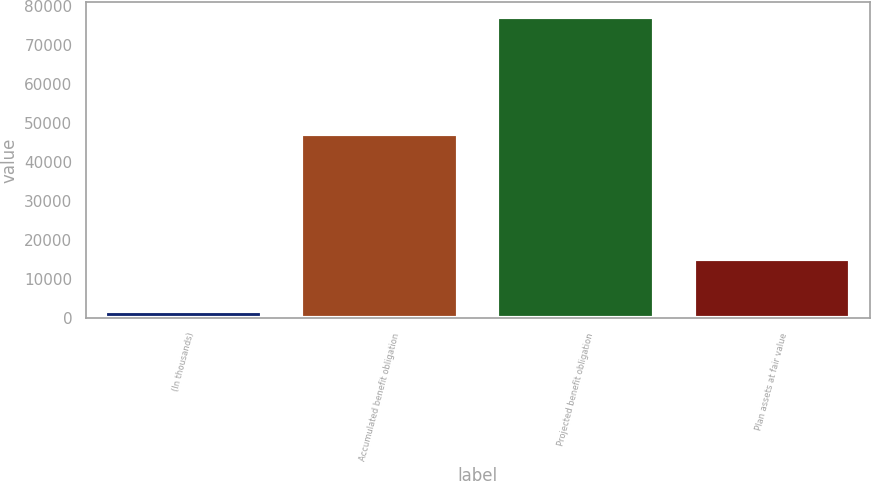<chart> <loc_0><loc_0><loc_500><loc_500><bar_chart><fcel>(In thousands)<fcel>Accumulated benefit obligation<fcel>Projected benefit obligation<fcel>Plan assets at fair value<nl><fcel>2014<fcel>47122<fcel>77035<fcel>15163<nl></chart> 